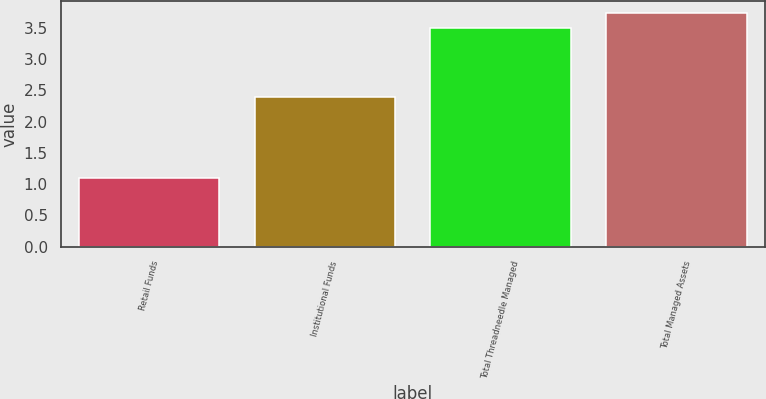<chart> <loc_0><loc_0><loc_500><loc_500><bar_chart><fcel>Retail Funds<fcel>Institutional Funds<fcel>Total Threadneedle Managed<fcel>Total Managed Assets<nl><fcel>1.1<fcel>2.4<fcel>3.5<fcel>3.74<nl></chart> 